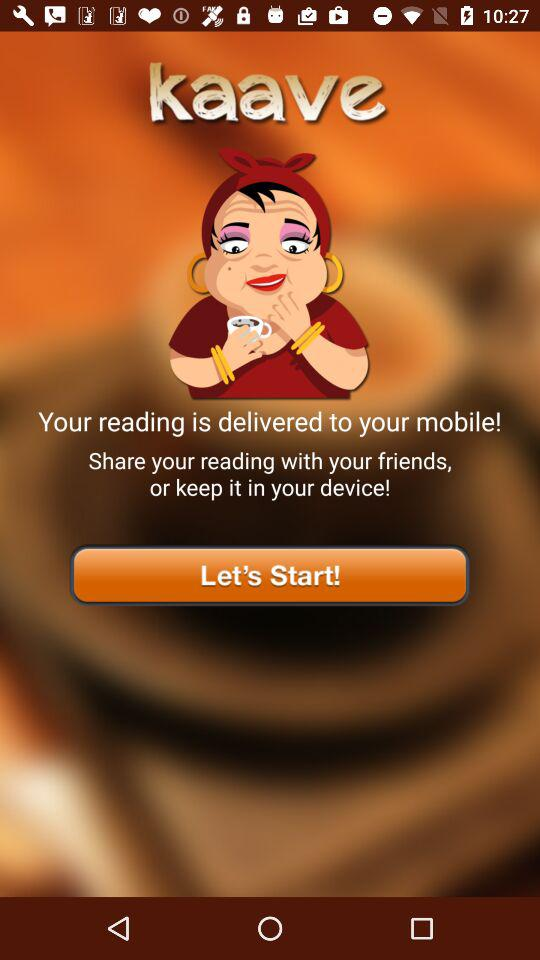What is the application name? The application name is "kaave". 